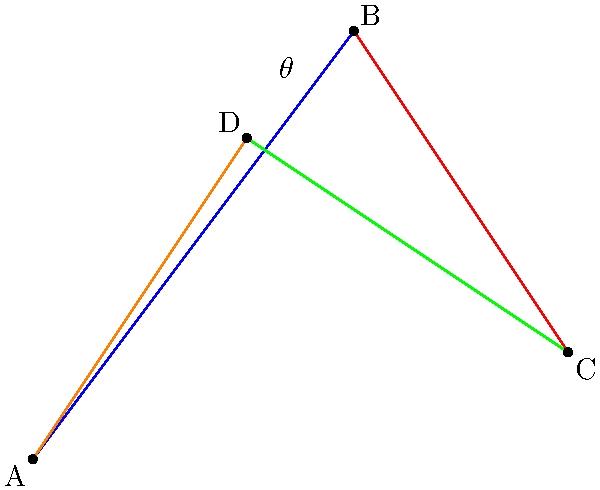In a Jackson Pollock-style drip painting, four prominent paint splatters form the vertices of a quadrilateral ABCD. The angle $\theta$ is formed by the intersection of paint drips AB and BC. If AB = 5 units, BC = 5 units, and AC = $\sqrt{50}$ units, what is the measure of angle $\theta$ in degrees? Let's approach this step-by-step:

1) We can use the law of cosines to find the angle $\theta$. The law of cosines states:
   
   $$c^2 = a^2 + b^2 - 2ab \cos(C)$$

   where $C$ is the angle opposite the side $c$.

2) In our case:
   - $a = AB = 5$
   - $b = BC = 5$
   - $c = AC = \sqrt{50}$
   - $C = \theta$

3) Substituting these values into the law of cosines:

   $$(\sqrt{50})^2 = 5^2 + 5^2 - 2(5)(5) \cos(\theta)$$

4) Simplify:
   
   $$50 = 25 + 25 - 50 \cos(\theta)$$

5) Solve for $\cos(\theta)$:
   
   $$50 \cos(\theta) = 50 - 50 = 0$$
   $$\cos(\theta) = 0$$

6) The inverse cosine (arccos) of 0 is 90°.

Therefore, the measure of angle $\theta$ is 90°.
Answer: 90° 